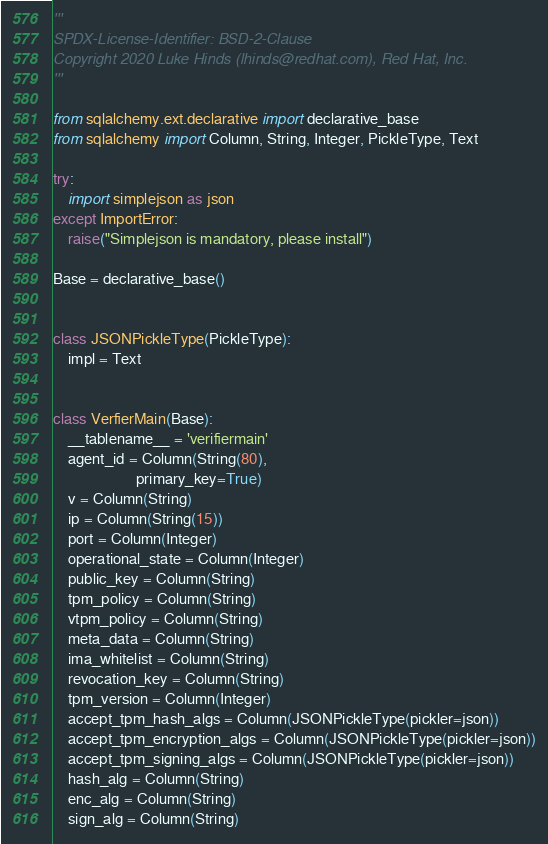<code> <loc_0><loc_0><loc_500><loc_500><_Python_>'''
SPDX-License-Identifier: BSD-2-Clause
Copyright 2020 Luke Hinds (lhinds@redhat.com), Red Hat, Inc.
'''

from sqlalchemy.ext.declarative import declarative_base
from sqlalchemy import Column, String, Integer, PickleType, Text

try:
    import simplejson as json
except ImportError:
    raise("Simplejson is mandatory, please install")

Base = declarative_base()


class JSONPickleType(PickleType):
    impl = Text


class VerfierMain(Base):
    __tablename__ = 'verifiermain'
    agent_id = Column(String(80),
                      primary_key=True)
    v = Column(String)
    ip = Column(String(15))
    port = Column(Integer)
    operational_state = Column(Integer)
    public_key = Column(String)
    tpm_policy = Column(String)
    vtpm_policy = Column(String)
    meta_data = Column(String)
    ima_whitelist = Column(String)
    revocation_key = Column(String)
    tpm_version = Column(Integer)
    accept_tpm_hash_algs = Column(JSONPickleType(pickler=json))
    accept_tpm_encryption_algs = Column(JSONPickleType(pickler=json))
    accept_tpm_signing_algs = Column(JSONPickleType(pickler=json))
    hash_alg = Column(String)
    enc_alg = Column(String)
    sign_alg = Column(String)
</code> 